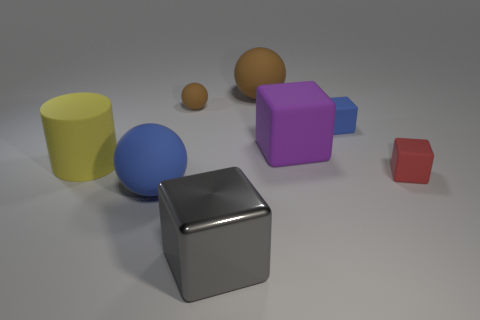Is there another big matte object of the same shape as the red matte object?
Your response must be concise. Yes. How many other large things are the same shape as the big blue object?
Offer a terse response. 1. Are there more big things than purple metal cylinders?
Your answer should be compact. Yes. What number of small objects are either purple matte objects or matte balls?
Offer a very short reply. 1. What number of other things are there of the same color as the tiny ball?
Your response must be concise. 1. How many gray blocks are the same material as the small brown thing?
Your answer should be very brief. 0. Do the ball to the right of the small sphere and the small sphere have the same color?
Your answer should be compact. Yes. What number of brown objects are cylinders or blocks?
Your answer should be very brief. 0. Is there anything else that is made of the same material as the gray object?
Your answer should be compact. No. Is the large cube in front of the large rubber cylinder made of the same material as the purple object?
Your answer should be compact. No. 